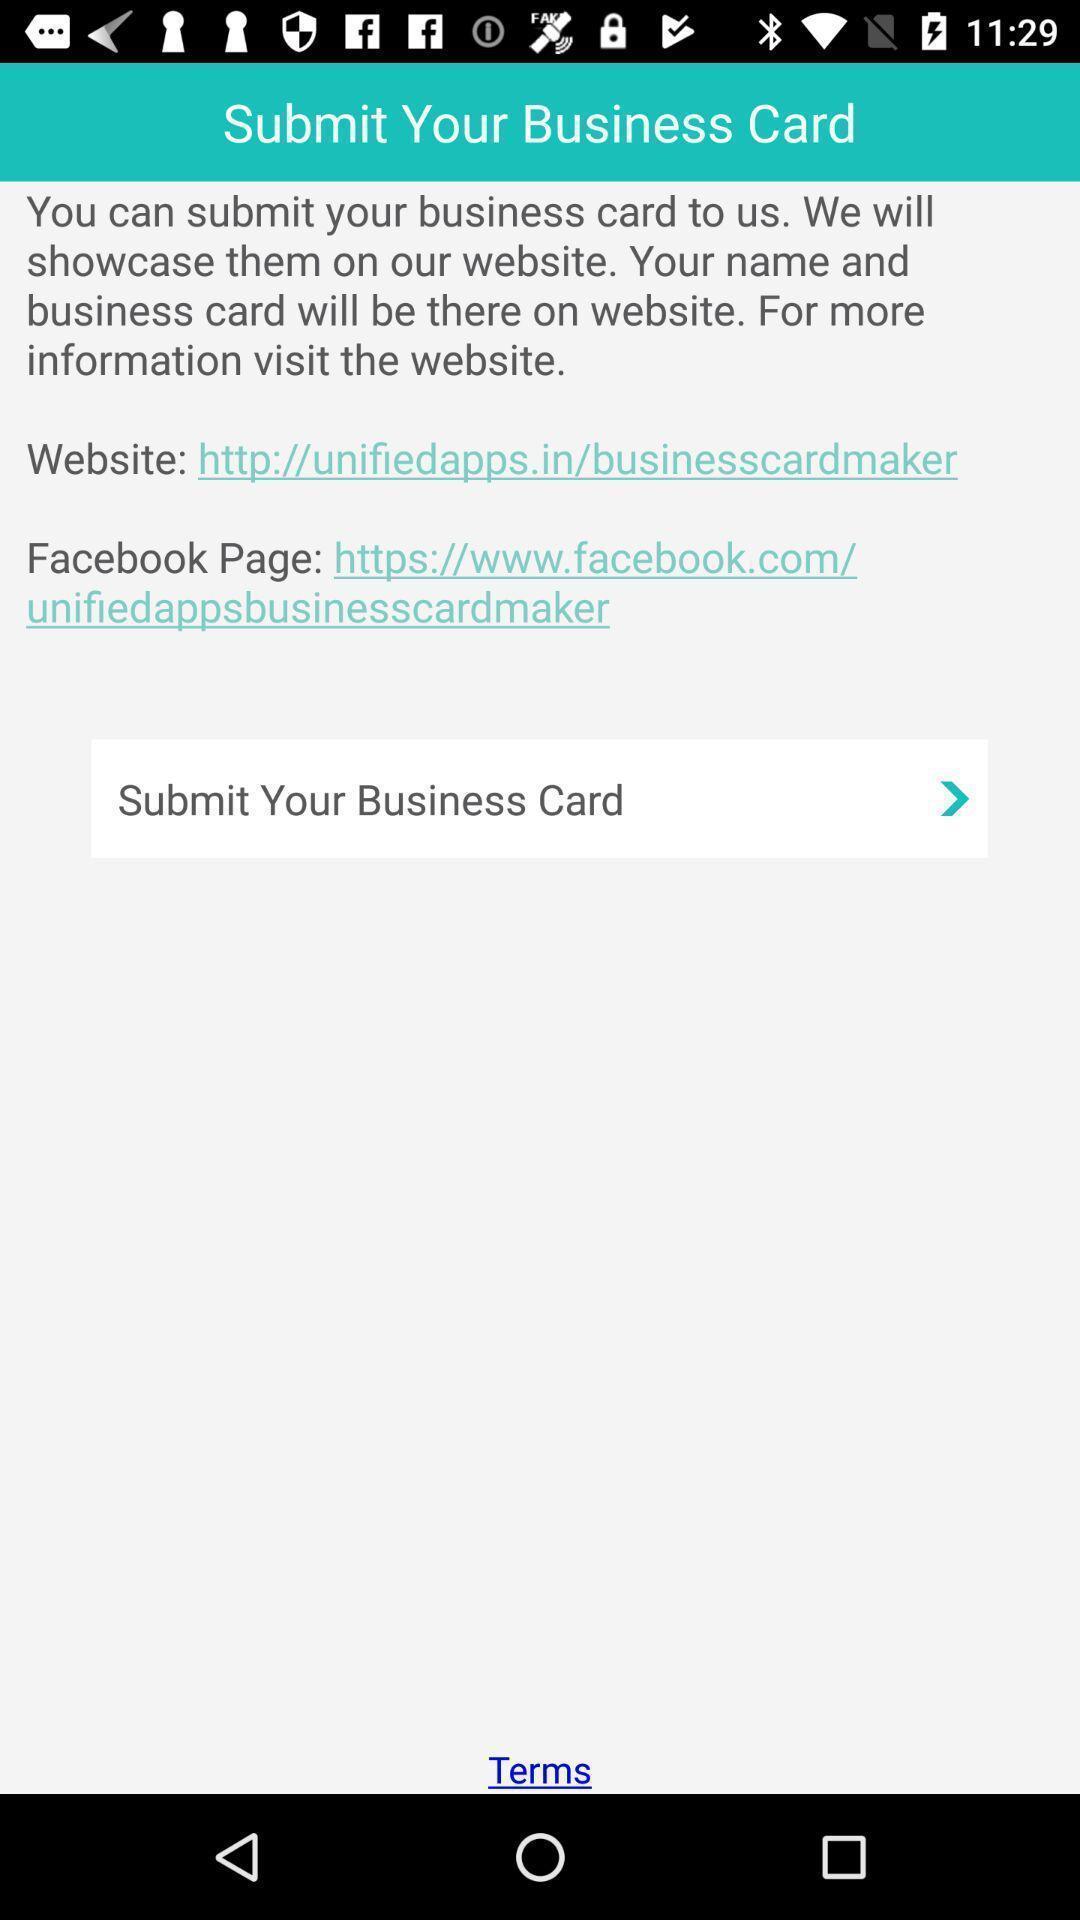Tell me what you see in this picture. Submit page. 